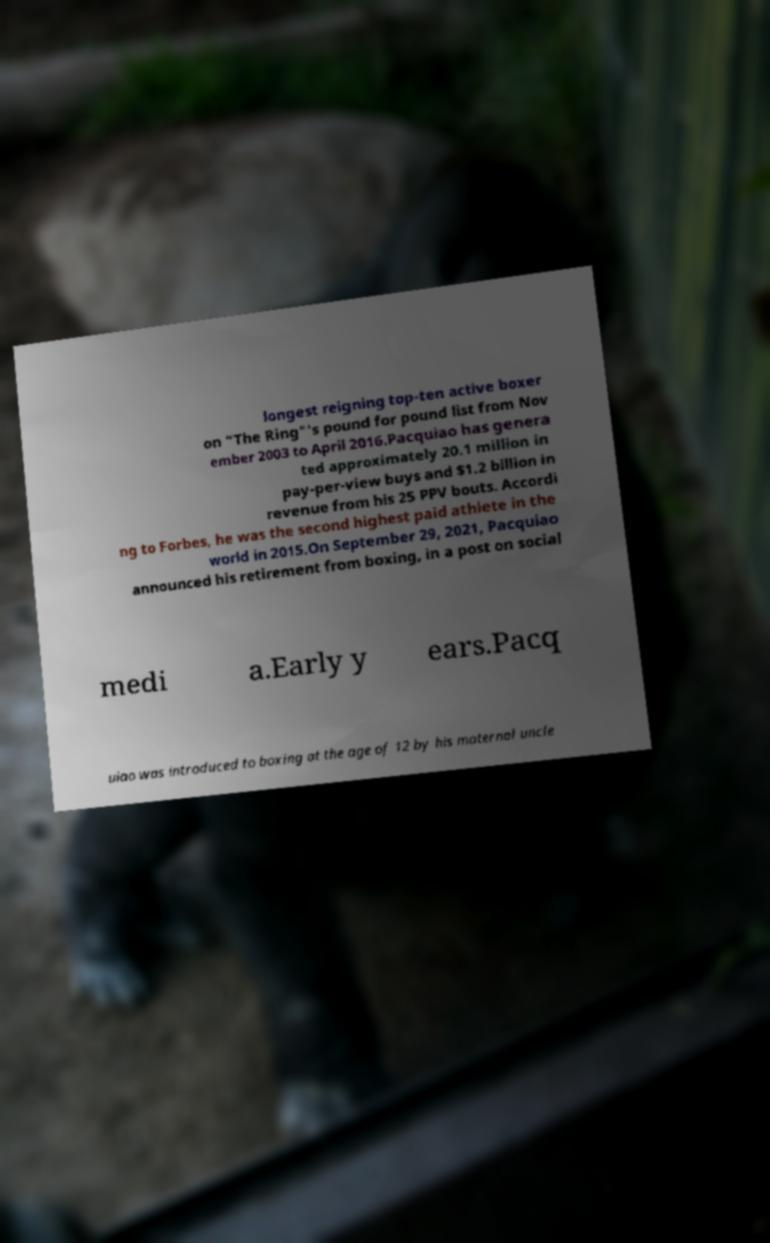Please read and relay the text visible in this image. What does it say? longest reigning top-ten active boxer on "The Ring"'s pound for pound list from Nov ember 2003 to April 2016.Pacquiao has genera ted approximately 20.1 million in pay-per-view buys and $1.2 billion in revenue from his 25 PPV bouts. Accordi ng to Forbes, he was the second highest paid athlete in the world in 2015.On September 29, 2021, Pacquiao announced his retirement from boxing, in a post on social medi a.Early y ears.Pacq uiao was introduced to boxing at the age of 12 by his maternal uncle 